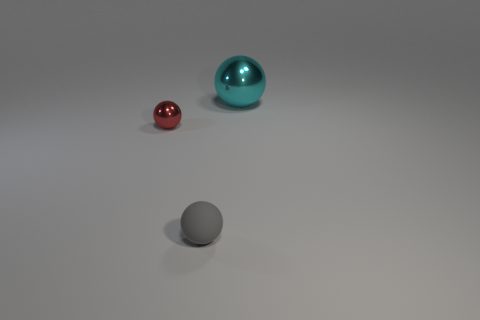Is there any other thing that has the same size as the cyan ball?
Give a very brief answer. No. There is a ball that is behind the small red metal thing; how big is it?
Your response must be concise. Large. What is the gray sphere made of?
Keep it short and to the point. Rubber. Is there a rubber sphere that has the same size as the red metallic object?
Keep it short and to the point. Yes. Is there a small sphere that is to the right of the shiny thing that is in front of the sphere that is right of the gray matte ball?
Offer a very short reply. Yes. What is the material of the small thing in front of the shiny thing that is to the left of the metal object that is on the right side of the small gray matte object?
Make the answer very short. Rubber. What is the shape of the shiny thing that is in front of the cyan metal sphere?
Ensure brevity in your answer.  Sphere. There is a red object that is the same material as the big cyan sphere; what is its size?
Offer a very short reply. Small. How many gray rubber objects have the same shape as the tiny red object?
Provide a short and direct response. 1. There is a ball that is in front of the tiny ball that is left of the tiny rubber object; how many gray rubber balls are on the right side of it?
Your answer should be very brief. 0. 